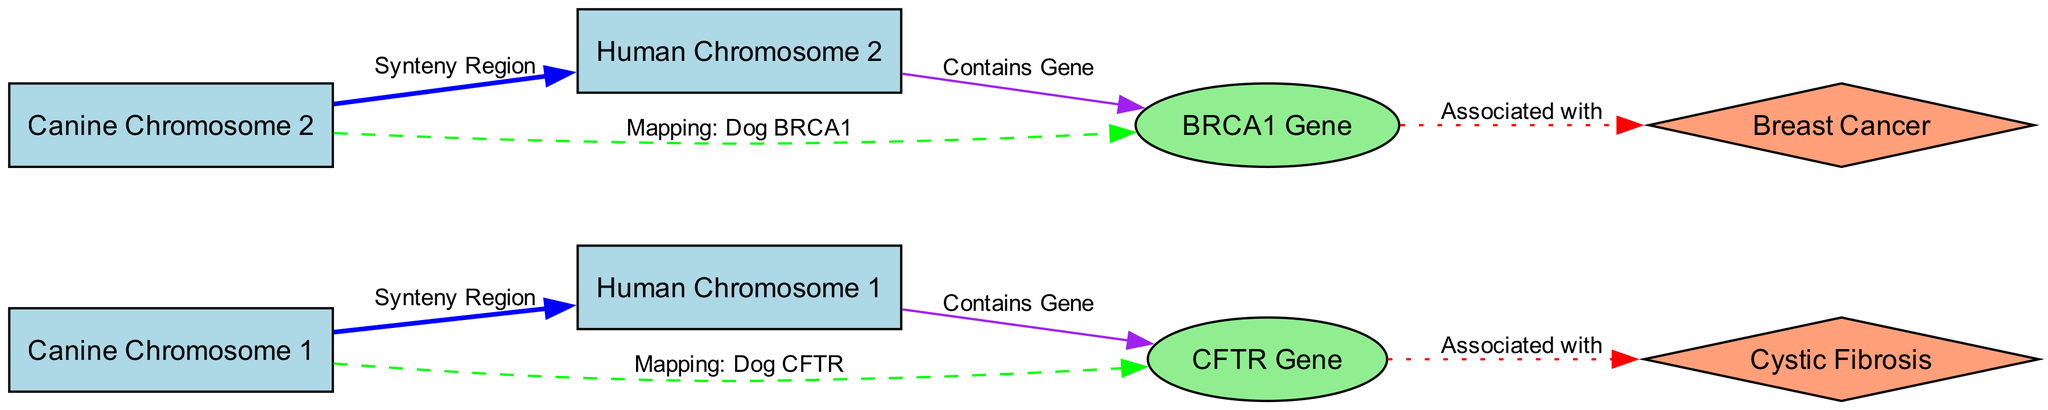What is the total number of nodes in the diagram? The diagram includes eight distinct nodes: two canine chromosomes (Canine Chromosome 1 and Canine Chromosome 2), two human chromosomes (Human Chromosome 1 and Human Chromosome 2), two genes (CFTR Gene and BRCA1 Gene), and two diseases (Cystic Fibrosis and Breast Cancer). Therefore, the total number of nodes is eight.
Answer: 8 Which canine chromosome is associated with the CFTR gene? The diagram shows a direct edge labeled "Mapping: Dog CFTR" connecting Canine Chromosome 1 to the CFTR Gene. This indicates that the CFTR gene is specifically associated with Canine Chromosome 1.
Answer: Canine Chromosome 1 How many edges in the diagram indicate a "Synteny Region"? There are two edges labeled "Synteny Region" that connect the canine chromosomes to the corresponding human chromosomes: one for Canine Chromosome 1 and another for Canine Chromosome 2. Thus, the total is two.
Answer: 2 What disease is associated with the BRCA1 gene? The diagram shows an edge labeled "Associated with" connecting the BRCA1 Gene to the disease Breast Cancer, indicating that the BRCA1 gene is directly associated with breast cancer.
Answer: Breast Cancer Which two genes are mapped in the diagram? The diagram presents the CFTR Gene and BRCA1 Gene, represented as distinct ellipses connected by edges to their respective canine chromosome mappings and associated diseases. Therefore, the two genes mapped are CFTR and BRCA1.
Answer: CFTR Gene, BRCA1 Gene Which chromosomes show synteny with Canine Chromosome 2? The diagram clearly indicates that the connection labeled "Synteny Region" for Canine Chromosome 2 is directed towards Human Chromosome 2, demonstrating that this relationship exists between these two specific chromosomes.
Answer: Human Chromosome 2 How is the relationship between the CFTR gene and Cystic Fibrosis depicted? The relationship is illustrated in the diagram by a dotted edge labeled "Associated with" that connects the CFTR Gene to the disease Cystic Fibrosis, indicating a direct association between the gene and the disease.
Answer: Associated with What color is used for canine chromosomes in the diagram? The canine chromosomes are represented using light blue nodes as defined in the diagram’s styling. This color distinctly indicates their category as chromosomes.
Answer: Light blue 